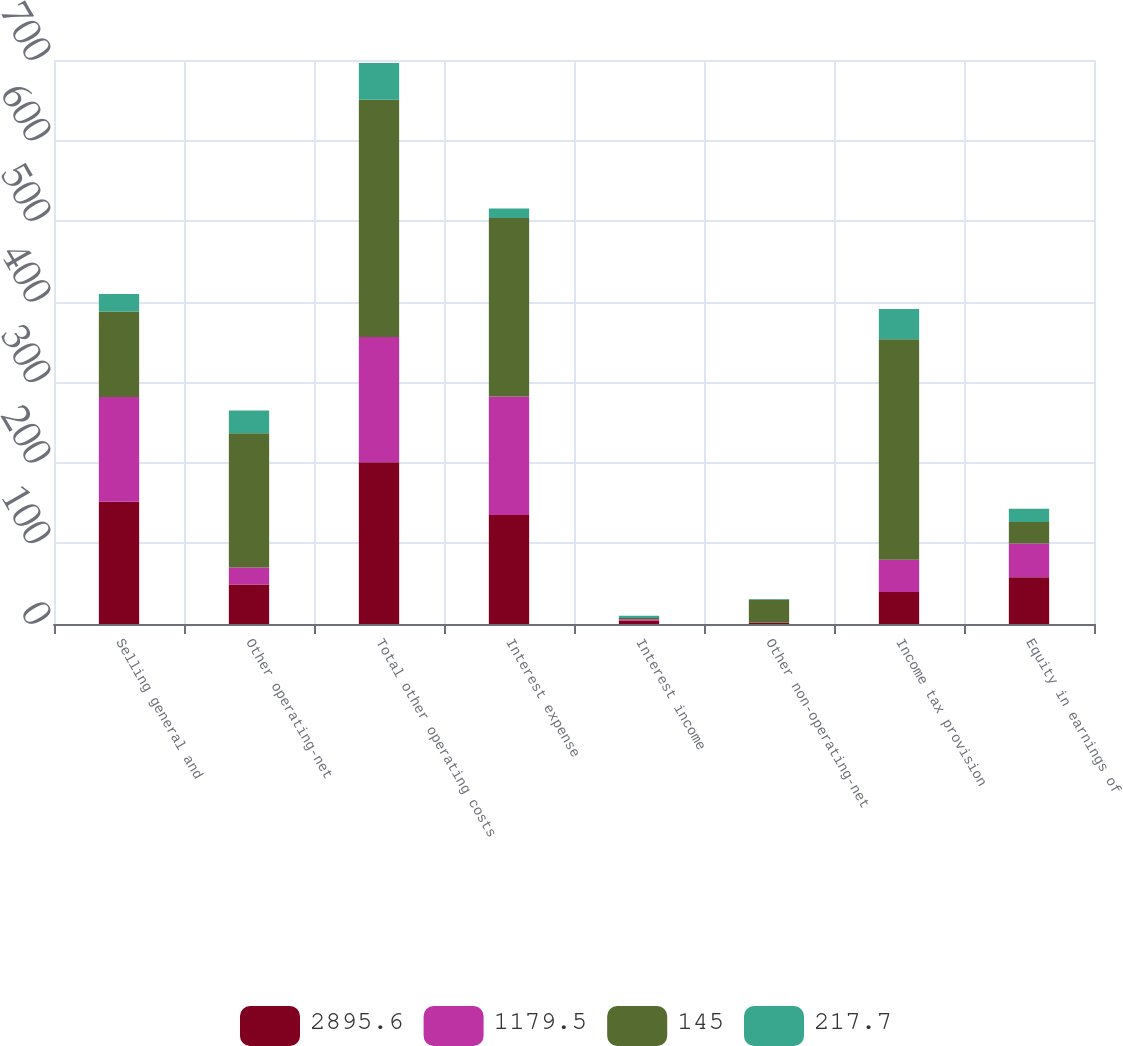Convert chart. <chart><loc_0><loc_0><loc_500><loc_500><stacked_bar_chart><ecel><fcel>Selling general and<fcel>Other operating-net<fcel>Total other operating costs<fcel>Interest expense<fcel>Interest income<fcel>Other non-operating-net<fcel>Income tax provision<fcel>Equity in earnings of<nl><fcel>2895.6<fcel>151.8<fcel>49.1<fcel>200.9<fcel>135.3<fcel>4.3<fcel>1.1<fcel>39.8<fcel>58.1<nl><fcel>1179.5<fcel>130<fcel>20.9<fcel>155.3<fcel>147.2<fcel>1.7<fcel>0.6<fcel>39.8<fcel>41.9<nl><fcel>145<fcel>106.1<fcel>166.7<fcel>294.4<fcel>221.3<fcel>1.5<fcel>28.8<fcel>273.7<fcel>26.7<nl><fcel>217.7<fcel>21.8<fcel>28.2<fcel>45.6<fcel>11.9<fcel>2.6<fcel>0.5<fcel>37.7<fcel>16.2<nl></chart> 